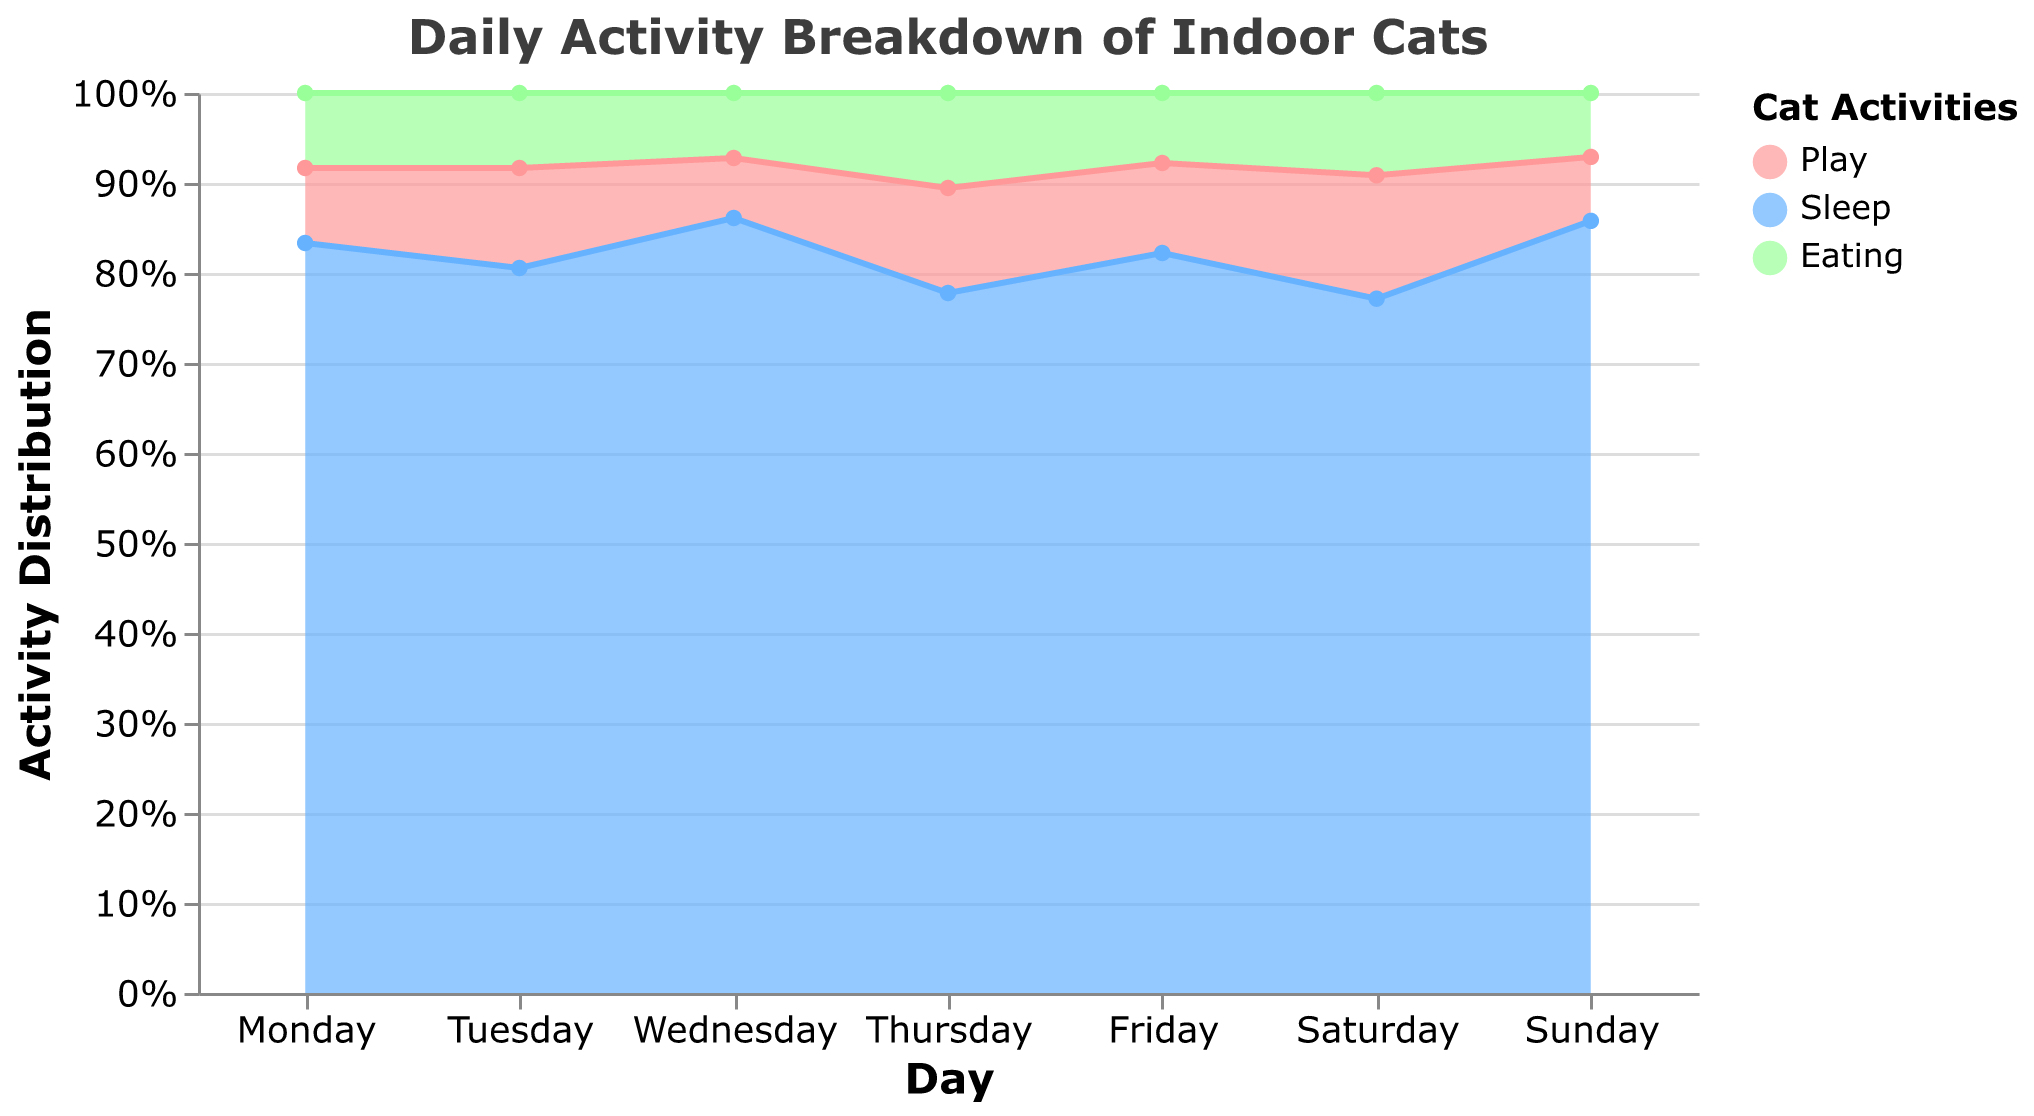What is the title of the figure? The title is shown at the top of the chart and is clearly readable.
Answer: Daily Activity Breakdown of Indoor Cats What activities are displayed in the chart? The chart shows activities in different colors labeled in the legend.
Answer: Play, Sleep, Eating On which day did cats spend the most time sleeping? Observing the height of the "Sleep" area across the days, Sunday has the highest value.
Answer: Sunday What is the color used to represent the "Play" activity? The color legend indicates the color associated with "Play."
Answer: Light Red How many hours did cats spend eating on Thursday? By hovering over or examining the "Eating" section for Thursday, the tooltip gives the specific duration.
Answer: 1.9 hours On which day did cats spend the least amount of time playing? Observing the "Play" sections, Wednesday has the smallest area for this activity.
Answer: Wednesday What is the average number of hours spent playing over the week? Sum the "Play" hours for each day and divide by 7: (1.5 + 2 + 1.2 + 2.1 + 1.8 + 2.4 + 1.3) / 7
Answer: 1.61 hours Which day has the highest total activity duration for "Eating" plus "Play"? Sum the "Eating" and "Play" durations for each day and compare. Thursday has the highest total: 1.9 + 2.1 = 4.0 hours
Answer: Thursday How does the sleep pattern vary from Monday to Sunday? Observing the "Sleep" areas from Monday to Sunday shows variation in the area height and duration values in the tooltip.
Answer: Varies from 13.5 to 15.7 hours Which activity has the most consistent duration throughout the week? Evaluate changes in height across the days for each activity; "Eating" has minimal variation.
Answer: Eating 